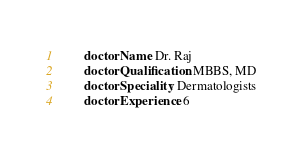<code> <loc_0><loc_0><loc_500><loc_500><_YAML_>        doctorName: Dr. Raj
        doctorQualification: MBBS, MD
        doctorSpeciality: Dermatologists
        doctorExperience: 6
</code> 